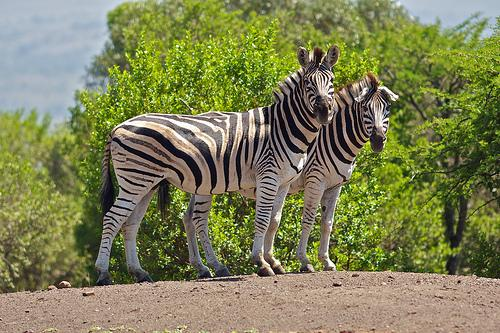Describe the environment where the zebras are. The zebras are in a natural setting with trees, dirt-covered ground, rocks, and mountains in the distance. Express the image's ambiance in a single sentence. A serene, peaceful moment captured as two zebras blend harmoniously with their natural surroundings. Provide a simple, visual summary of the image. Two zebras in a forested area with several rocks and soil amidst a backdrop of hazy mountains. Describe how the zebras in the image are positioned. The zebras are standing close together, side by side, surrounded by trees with their hooves on the ground. What is the most striking feature of the zebras in the image? The zebras have prominent black stripes on their bodies, while one zebra looks directly at the camera. What colors and patterns can you see on the zebras? The zebras have black and white stripes on their bodies, white ankles, and black hoofs. What kind of ground are the zebras standing on, and what objects can be seen on it? The zebras are standing on brown soil with various rocks scattered across the surface. Use a metaphor to describe the scene in the image. The zebras stand like black-and-white paintings in a vivid, wild gallery of nature. Mention the primary elements of the scene you noticed first. Two zebras side by side, surrounded by trees, with mountains in the distance, standing on sandy, rocky ground. What do you find interesting about one of the zebras' facial features? One zebra has a black nose and white ears, appearing attentive as it gazes into the camera. 